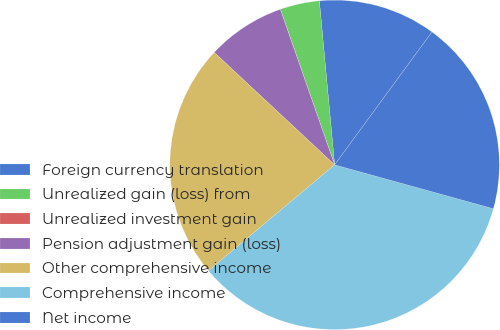<chart> <loc_0><loc_0><loc_500><loc_500><pie_chart><fcel>Foreign currency translation<fcel>Unrealized gain (loss) from<fcel>Unrealized investment gain<fcel>Pension adjustment gain (loss)<fcel>Other comprehensive income<fcel>Comprehensive income<fcel>Net income<nl><fcel>11.54%<fcel>3.86%<fcel>0.01%<fcel>7.7%<fcel>23.07%<fcel>34.59%<fcel>19.23%<nl></chart> 